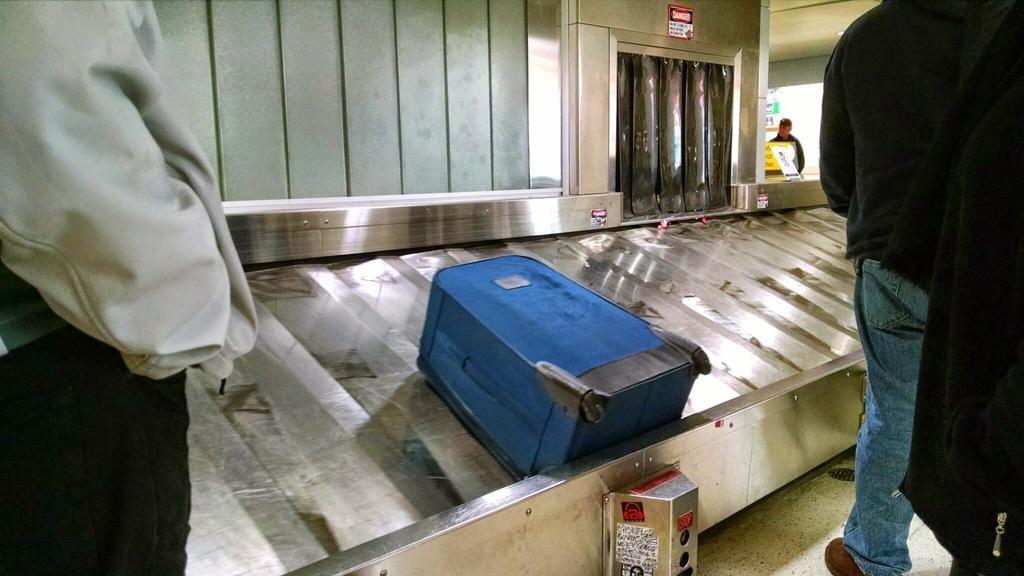How would you summarize this image in a sentence or two? In this image I can see few people standing and wearing the white and black color dress. In-front of these people I can see the blue color bag on the conveyor belt. In the back I can see one person and there are boards in-front of that person. 